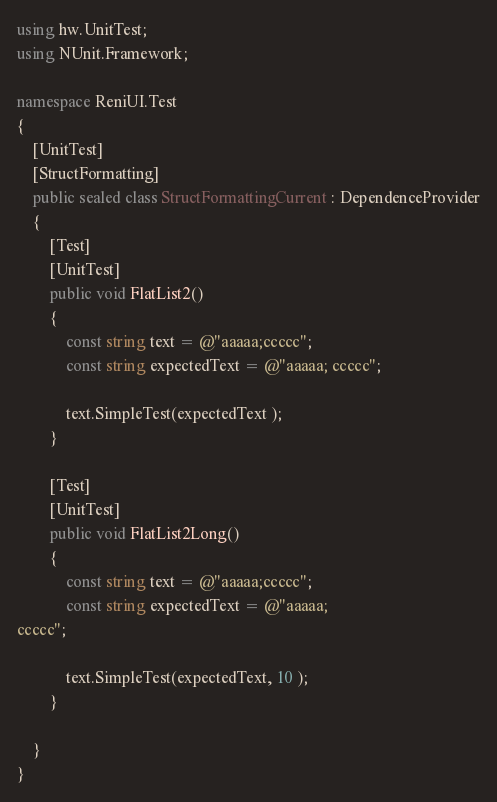<code> <loc_0><loc_0><loc_500><loc_500><_C#_>using hw.UnitTest;
using NUnit.Framework;

namespace ReniUI.Test
{
    [UnitTest]
    [StructFormatting]
    public sealed class StructFormattingCurrent : DependenceProvider
    {
        [Test]
        [UnitTest]
        public void FlatList2()
        {
            const string text = @"aaaaa;ccccc";
            const string expectedText = @"aaaaa; ccccc";

            text.SimpleTest(expectedText );
        }

        [Test]
        [UnitTest]
        public void FlatList2Long()
        {
            const string text = @"aaaaa;ccccc";
            const string expectedText = @"aaaaa;
ccccc";

            text.SimpleTest(expectedText, 10 );
        }

    }
}</code> 